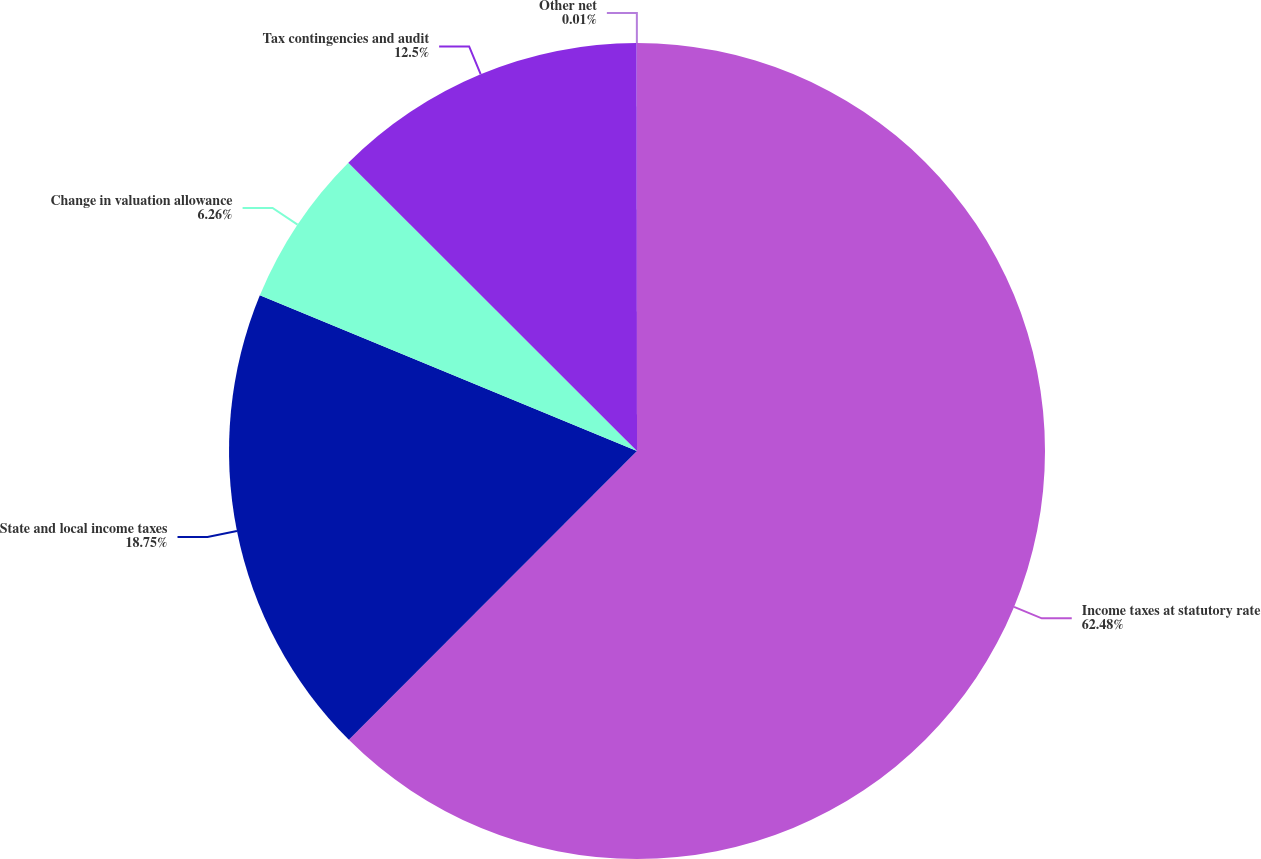Convert chart to OTSL. <chart><loc_0><loc_0><loc_500><loc_500><pie_chart><fcel>Income taxes at statutory rate<fcel>State and local income taxes<fcel>Change in valuation allowance<fcel>Tax contingencies and audit<fcel>Other net<nl><fcel>62.48%<fcel>18.75%<fcel>6.26%<fcel>12.5%<fcel>0.01%<nl></chart> 